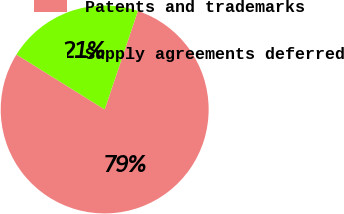<chart> <loc_0><loc_0><loc_500><loc_500><pie_chart><fcel>Patents and trademarks<fcel>Supply agreements deferred<nl><fcel>78.69%<fcel>21.31%<nl></chart> 